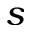Convert formula to latex. <formula><loc_0><loc_0><loc_500><loc_500>s</formula> 